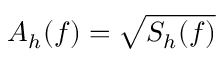Convert formula to latex. <formula><loc_0><loc_0><loc_500><loc_500>A _ { h } ( f ) = \sqrt { S _ { h } ( f ) }</formula> 